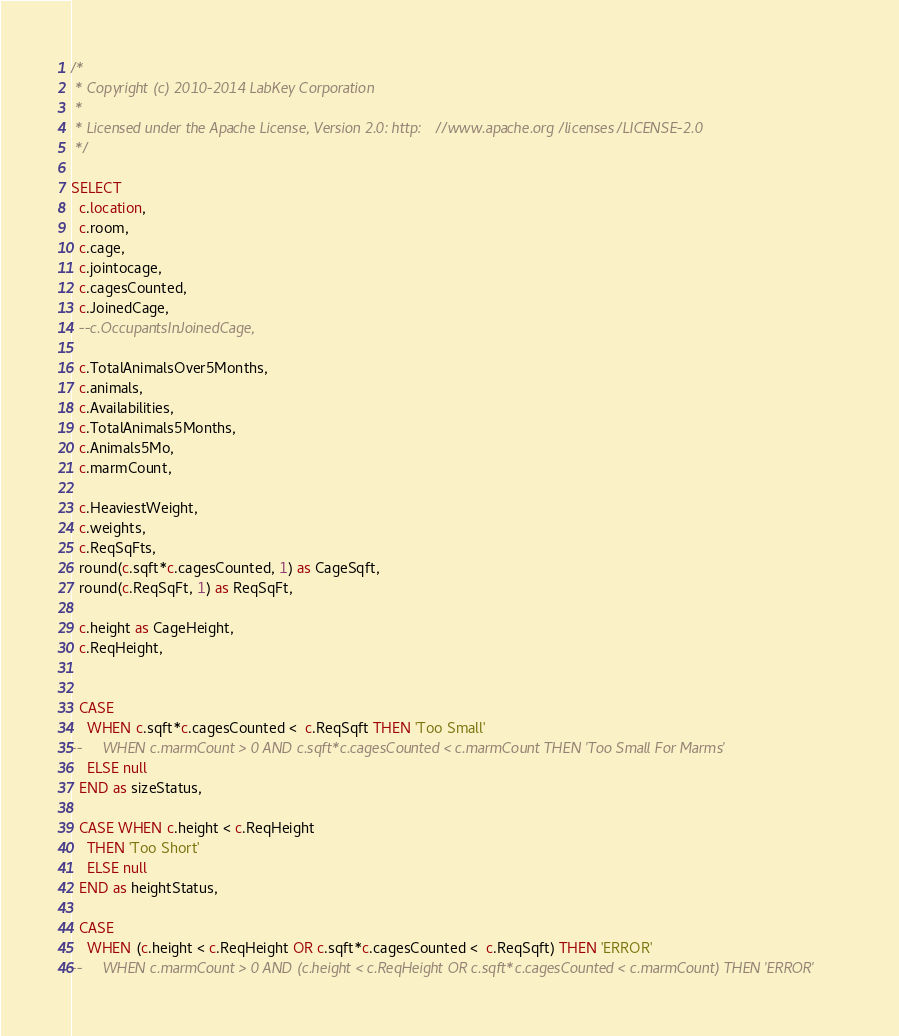Convert code to text. <code><loc_0><loc_0><loc_500><loc_500><_SQL_>/*
 * Copyright (c) 2010-2014 LabKey Corporation
 *
 * Licensed under the Apache License, Version 2.0: http://www.apache.org/licenses/LICENSE-2.0
 */

SELECT
  c.location,
  c.room,
  c.cage,
  c.jointocage,
  c.cagesCounted,
  c.JoinedCage,
  --c.OccupantsInJoinedCage,

  c.TotalAnimalsOver5Months,
  c.animals,
  c.Availabilities,
  c.TotalAnimals5Months,
  c.Animals5Mo,
  c.marmCount,

  c.HeaviestWeight,
  c.weights,
  c.ReqSqFts,
  round(c.sqft*c.cagesCounted, 1) as CageSqft,
  round(c.ReqSqFt, 1) as ReqSqFt,

  c.height as CageHeight,
  c.ReqHeight,


  CASE
    WHEN c.sqft*c.cagesCounted <  c.ReqSqft THEN 'Too Small'
--     WHEN c.marmCount > 0 AND c.sqft*c.cagesCounted < c.marmCount THEN 'Too Small For Marms'
    ELSE null
  END as sizeStatus,

  CASE WHEN c.height < c.ReqHeight
    THEN 'Too Short'
    ELSE null
  END as heightStatus,

  CASE
    WHEN (c.height < c.ReqHeight OR c.sqft*c.cagesCounted <  c.ReqSqft) THEN 'ERROR'
--     WHEN c.marmCount > 0 AND (c.height < c.ReqHeight OR c.sqft*c.cagesCounted < c.marmCount) THEN 'ERROR'</code> 